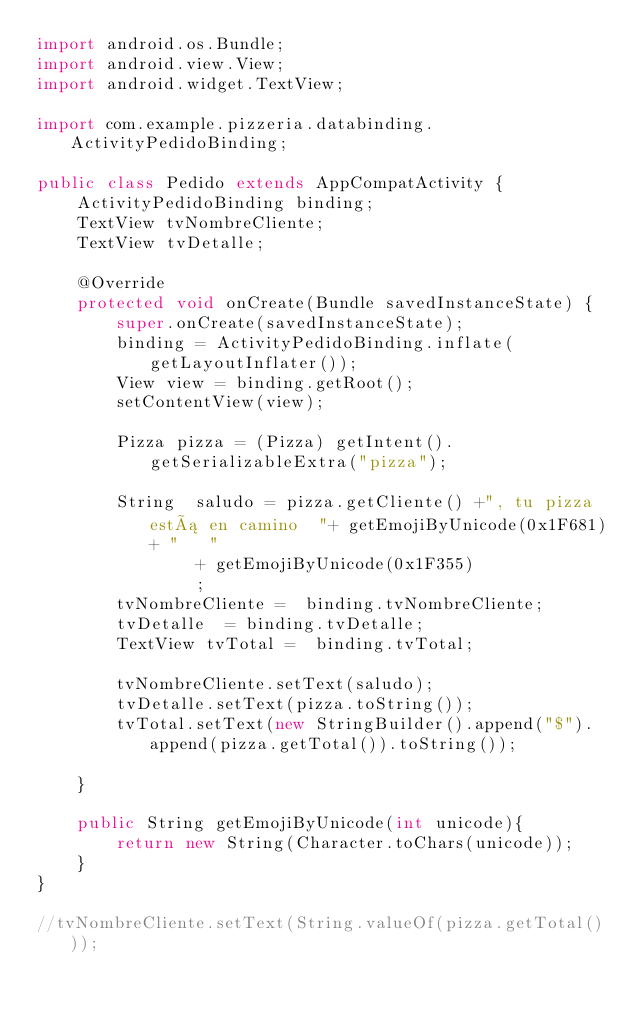Convert code to text. <code><loc_0><loc_0><loc_500><loc_500><_Java_>import android.os.Bundle;
import android.view.View;
import android.widget.TextView;

import com.example.pizzeria.databinding.ActivityPedidoBinding;

public class Pedido extends AppCompatActivity {
    ActivityPedidoBinding binding;
    TextView tvNombreCliente;
    TextView tvDetalle;

    @Override
    protected void onCreate(Bundle savedInstanceState) {
        super.onCreate(savedInstanceState);
        binding = ActivityPedidoBinding.inflate(getLayoutInflater());
        View view = binding.getRoot();
        setContentView(view);

        Pizza pizza = (Pizza) getIntent().getSerializableExtra("pizza");

        String  saludo = pizza.getCliente() +", tu pizza está en camino  "+ getEmojiByUnicode(0x1F681)+ "   "
                + getEmojiByUnicode(0x1F355)
                ;
        tvNombreCliente =  binding.tvNombreCliente;
        tvDetalle  = binding.tvDetalle;
        TextView tvTotal =  binding.tvTotal;

        tvNombreCliente.setText(saludo);
        tvDetalle.setText(pizza.toString());
        tvTotal.setText(new StringBuilder().append("$").append(pizza.getTotal()).toString());

    }

    public String getEmojiByUnicode(int unicode){
        return new String(Character.toChars(unicode));
    }
}

//tvNombreCliente.setText(String.valueOf(pizza.getTotal()));</code> 